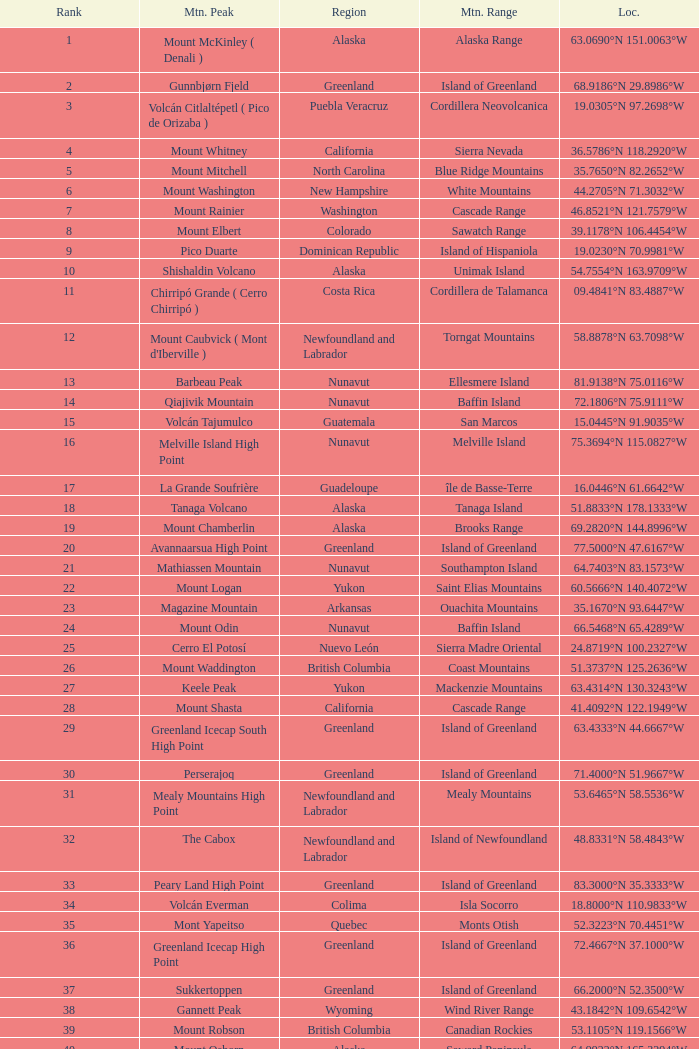In which region can the dillingham high point mountain peak be found? Alaska. 